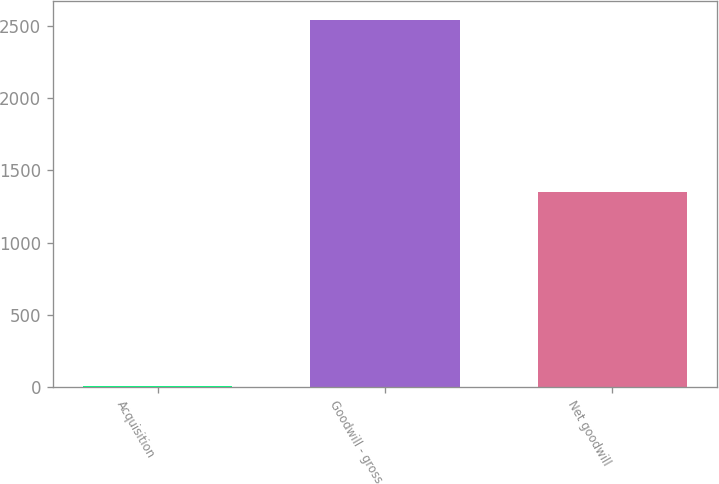<chart> <loc_0><loc_0><loc_500><loc_500><bar_chart><fcel>Acquisition<fcel>Goodwill - gross<fcel>Net goodwill<nl><fcel>3<fcel>2546<fcel>1350<nl></chart> 